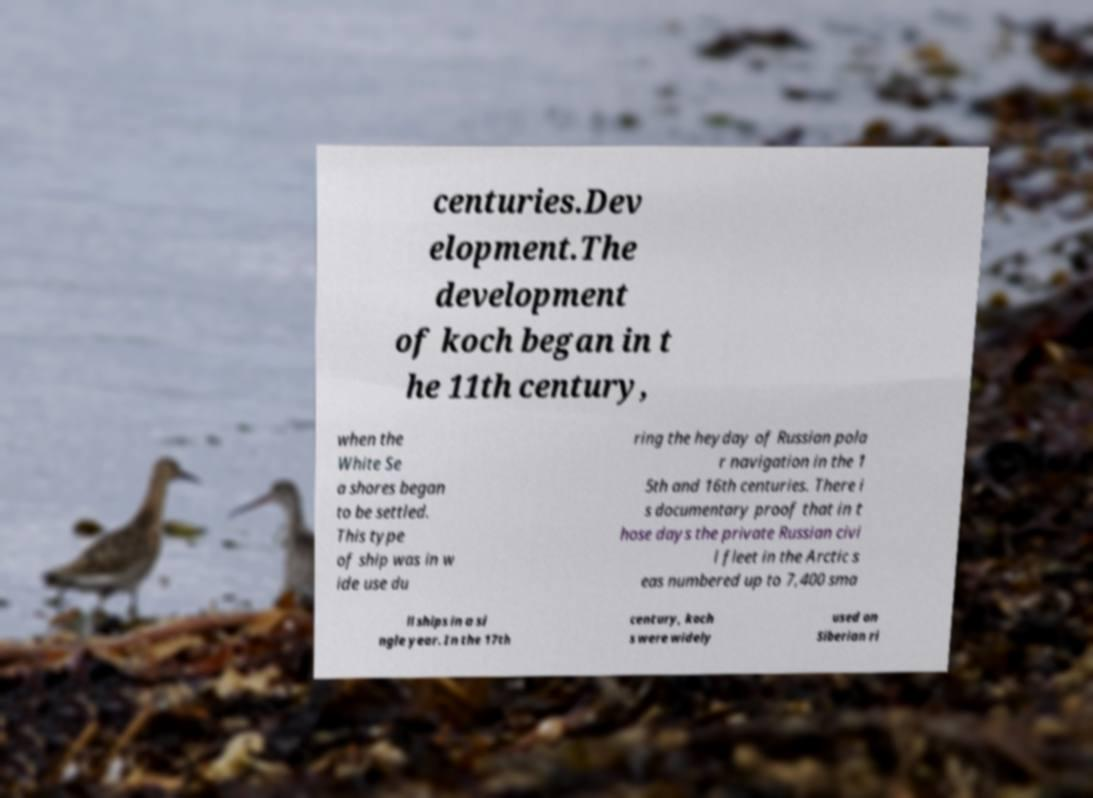For documentation purposes, I need the text within this image transcribed. Could you provide that? centuries.Dev elopment.The development of koch began in t he 11th century, when the White Se a shores began to be settled. This type of ship was in w ide use du ring the heyday of Russian pola r navigation in the 1 5th and 16th centuries. There i s documentary proof that in t hose days the private Russian civi l fleet in the Arctic s eas numbered up to 7,400 sma ll ships in a si ngle year. In the 17th century, koch s were widely used on Siberian ri 